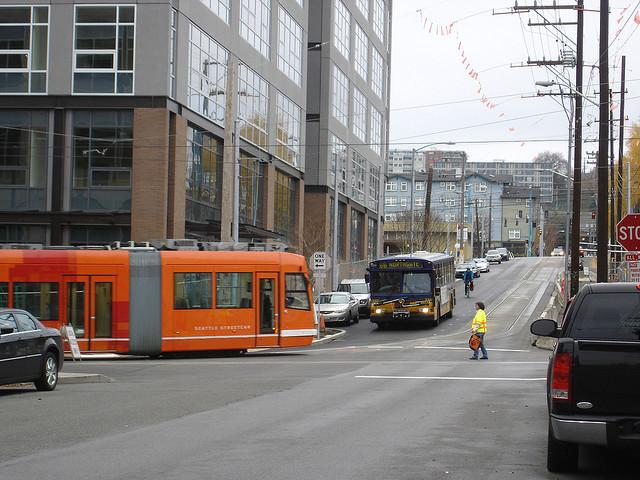What is the reason for the woman in yellow standing in the street here?

Choices:
A) drunk test
B) road construction
C) police stop
D) trapping robbers road construction 